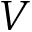Convert formula to latex. <formula><loc_0><loc_0><loc_500><loc_500>V</formula> 